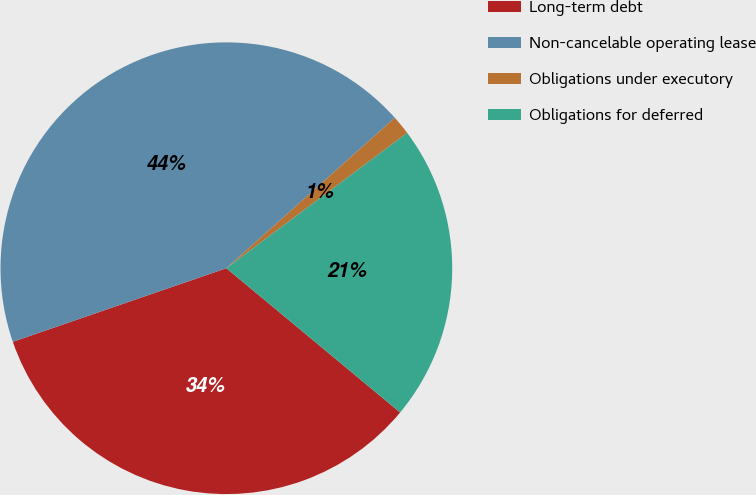Convert chart. <chart><loc_0><loc_0><loc_500><loc_500><pie_chart><fcel>Long-term debt<fcel>Non-cancelable operating lease<fcel>Obligations under executory<fcel>Obligations for deferred<nl><fcel>33.69%<fcel>43.68%<fcel>1.38%<fcel>21.25%<nl></chart> 